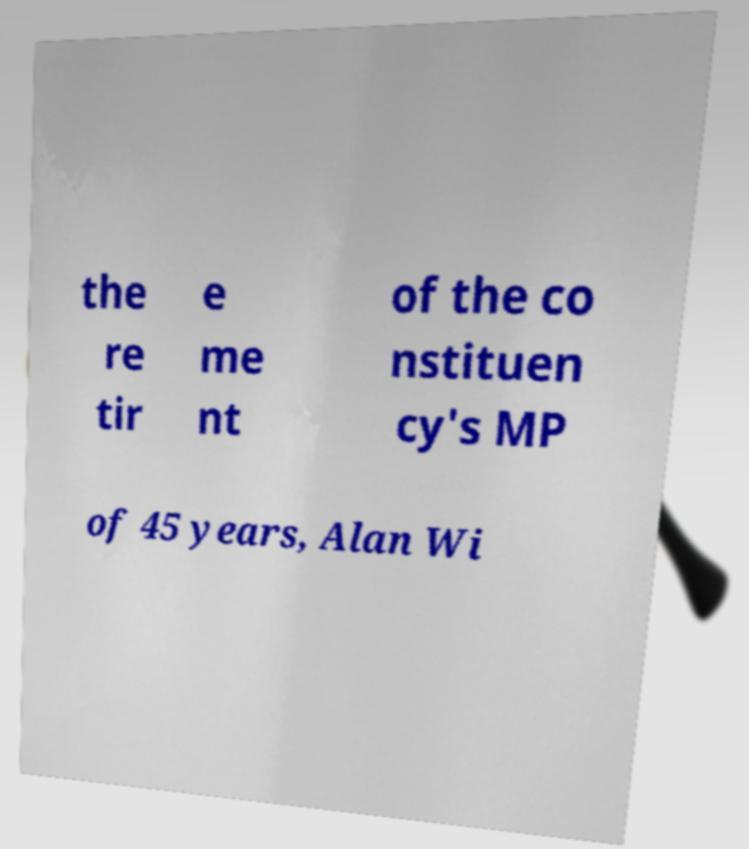For documentation purposes, I need the text within this image transcribed. Could you provide that? the re tir e me nt of the co nstituen cy's MP of 45 years, Alan Wi 